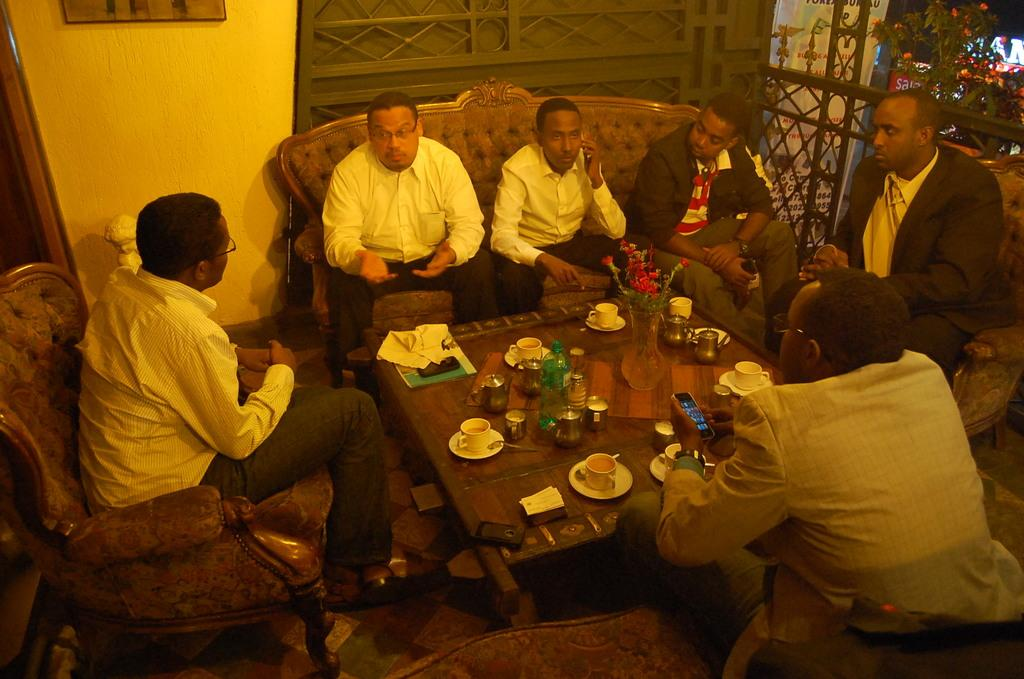How many persons are visible in the image? There are persons sitting on the couch and chair in the image. What are the persons sitting near? The persons are in front of a glass table. What can be seen on the table? There are cups of tea on the table. Are there any other items on the table besides the cups of tea? Yes, there are other items on the table. What is causing the persons to feel angry in the image? There is no indication in the image that the persons are feeling angry. --- Facts: 1. There is a person holding a book. 2. The person is sitting on a chair. 3. There is a desk in front of the person. 4. The desk has a lamp on it. 5. There is a window behind the person. Absurd Topics: dance, ocean, volcano Conversation: What is the person holding in the image? The person is holding a book in the image. Where is the person sitting? The person is sitting on a chair in the image. What is in front of the person? There is a desk in front of the person. What can be seen on the desk? The desk has a lamp on it. What is visible behind the person? There is a window behind the person. Reasoning: Let's think step by step in order to produce the conversation. We start by identifying the main subject in the image, which is the person holding a book. Then, we describe the person's location and the objects they are near, such as the chair, desk, and lamp. Finally, we mention the window visible behind the person. Each question is designed to elicit a specific detail about the image that is known from the provided facts. Absurd Question/Answer: Can you see the ocean from the window in the image? There is no ocean visible from the window in the image. 